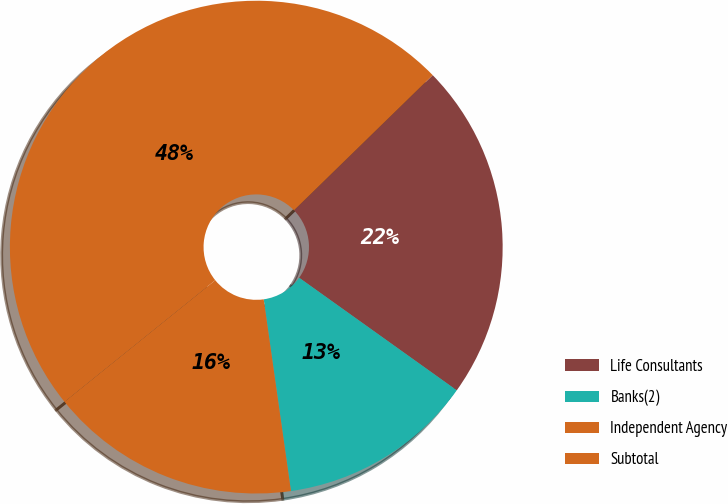Convert chart. <chart><loc_0><loc_0><loc_500><loc_500><pie_chart><fcel>Life Consultants<fcel>Banks(2)<fcel>Independent Agency<fcel>Subtotal<nl><fcel>22.17%<fcel>12.88%<fcel>16.45%<fcel>48.5%<nl></chart> 